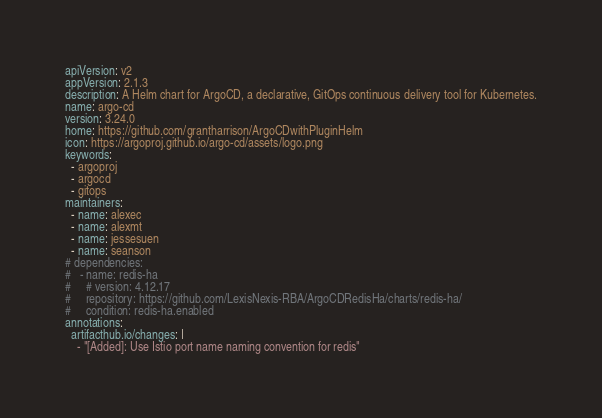<code> <loc_0><loc_0><loc_500><loc_500><_YAML_>apiVersion: v2
appVersion: 2.1.3
description: A Helm chart for ArgoCD, a declarative, GitOps continuous delivery tool for Kubernetes.
name: argo-cd
version: 3.24.0
home: https://github.com/grantharrison/ArgoCDwithPluginHelm
icon: https://argoproj.github.io/argo-cd/assets/logo.png
keywords:
  - argoproj
  - argocd
  - gitops
maintainers:
  - name: alexec
  - name: alexmt
  - name: jessesuen
  - name: seanson
# dependencies:
#   - name: redis-ha
#     # version: 4.12.17
#     repository: https://github.com/LexisNexis-RBA/ArgoCDRedisHa/charts/redis-ha/
#     condition: redis-ha.enabled
annotations:
  artifacthub.io/changes: |
    - "[Added]: Use Istio port name naming convention for redis"
</code> 